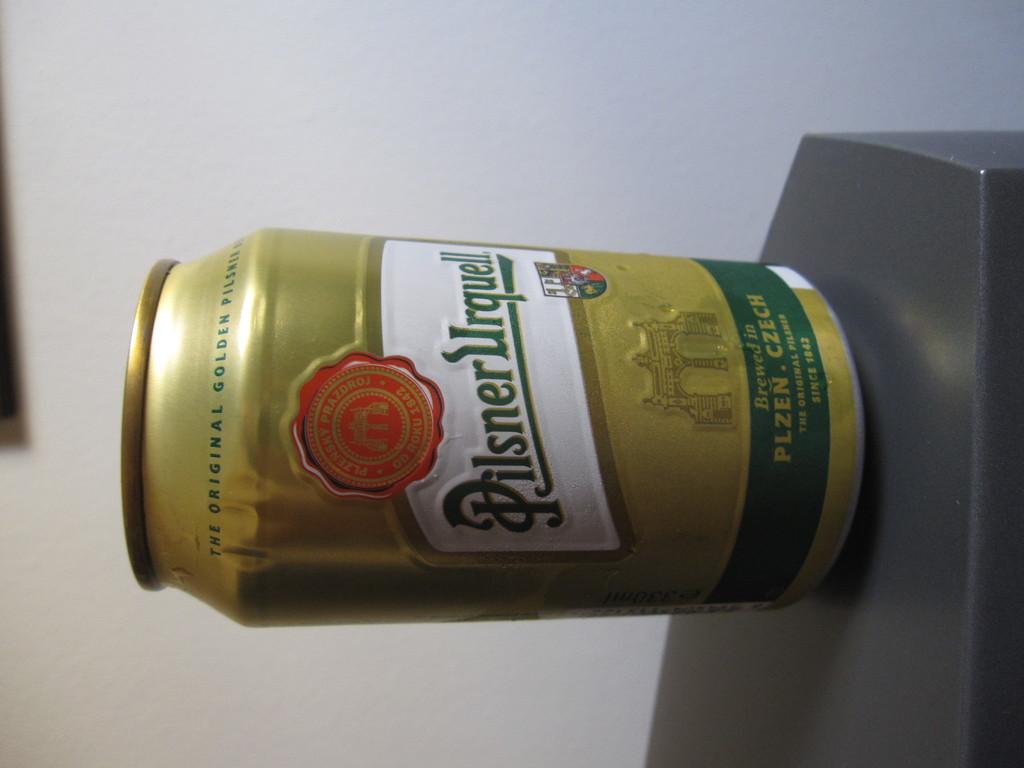Is a pilsner a beer?
Your answer should be very brief. Yes. What year was this brand of ale founded?
Make the answer very short. 1842. 